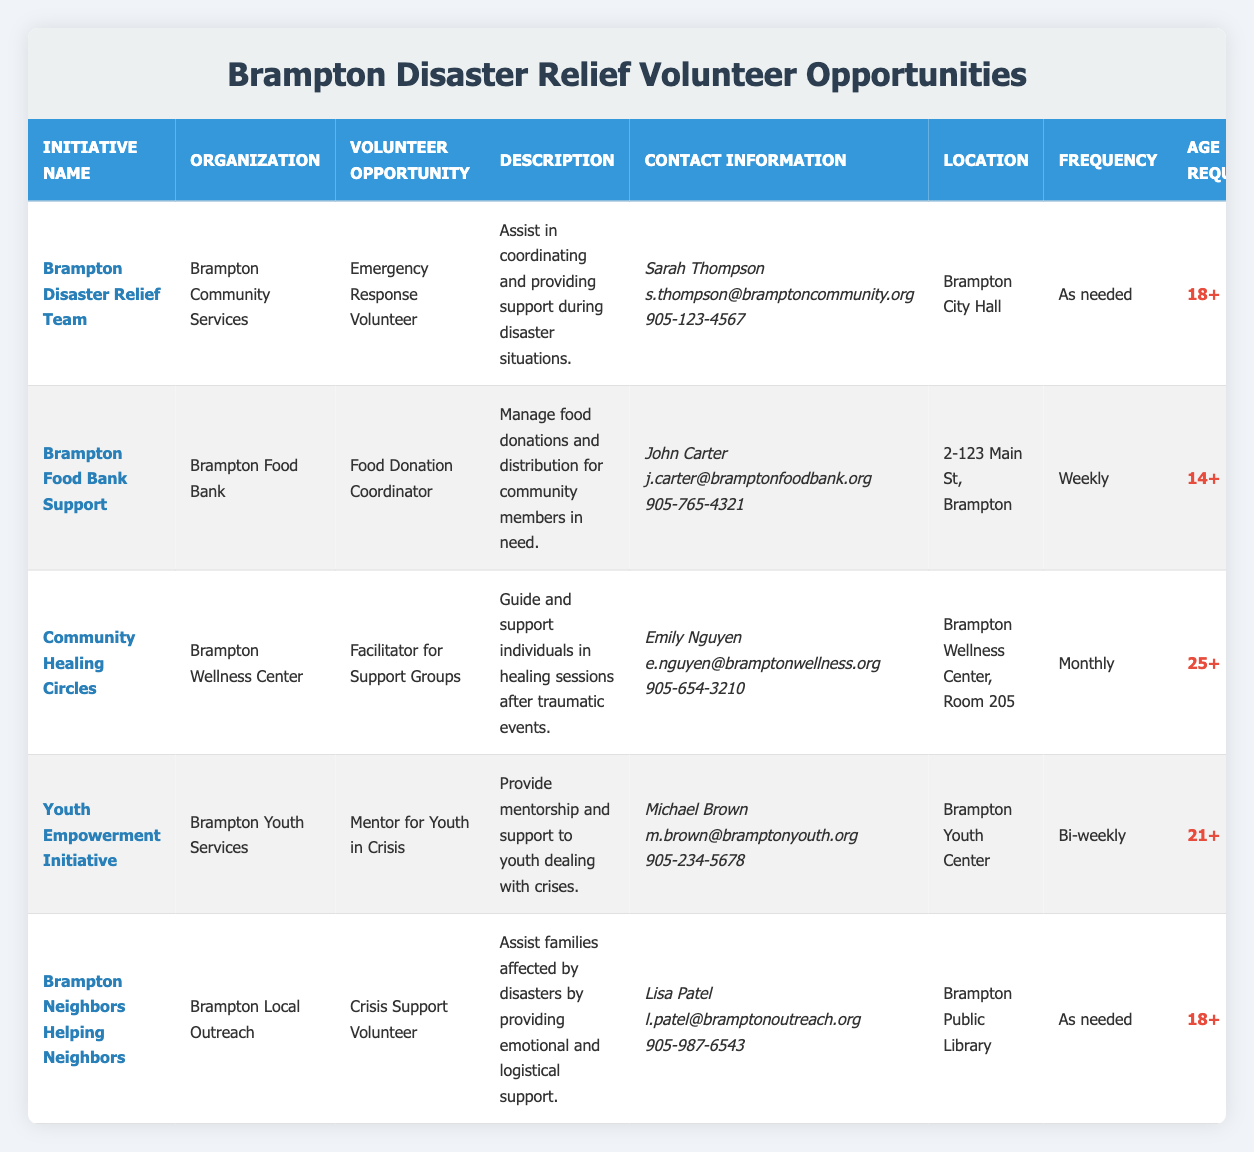What is the email contact for the Brampton Food Bank Support initiative? The table lists the contact email for the Brampton Food Bank Support, which is John Carter's email. The specific email given is j.carter@bramptonfoodbank.org.
Answer: j.carter@bramptonfoodbank.org How often do volunteers for Community Healing Circles meet? According to the table, the frequency for the Community Healing Circles volunteer opportunity is stated as "Monthly."
Answer: Monthly Are there any volunteer opportunities that require an age of 14 or older? By examining the age requirement column, we find that the Brampton Food Bank Support initiative requires 14+, indicating that it is available for those aged 14 and older.
Answer: Yes How many volunteer opportunities listed are available for individuals under 21 years? There are two opportunities: Brampton Food Bank Support (14+) and Brampton Neighbors Helping Neighbors (18+). This means volunteers aged 14 and up can participate, which indicates 2 opportunities suitable for individuals under 21.
Answer: 2 Which initiative provides mentorship to youth in crisis? The table identifies the Youth Empowerment Initiative as the program that offers a volunteer opportunity as a mentor for youth in crisis. The corresponding organization is Brampton Youth Services.
Answer: Youth Empowerment Initiative What is the contact number for the Crisis Support Volunteer opportunity? The contact number is provided in the table within the 'Contact Information' section for Brampton Neighbors Helping Neighbors, which lists Lisa Patel's number as 905-987-6543.
Answer: 905-987-6543 Which initiative requires the highest minimum age for volunteering, and what is that age? Looking at the age requirement column, Community Healing Circles requires volunteers to be 25+, which is the highest age requirement presented among all initiatives.
Answer: 25+ How does the frequency of volunteering differ between the Brampton Disaster Relief Team and the Brampton Food Bank Support? The Brampton Disaster Relief Team's volunteering frequency is "As needed," while the Brampton Food Bank Support has a "Weekly" schedule, showing a difference in the commitment level required between the two.
Answer: As needed vs. Weekly 